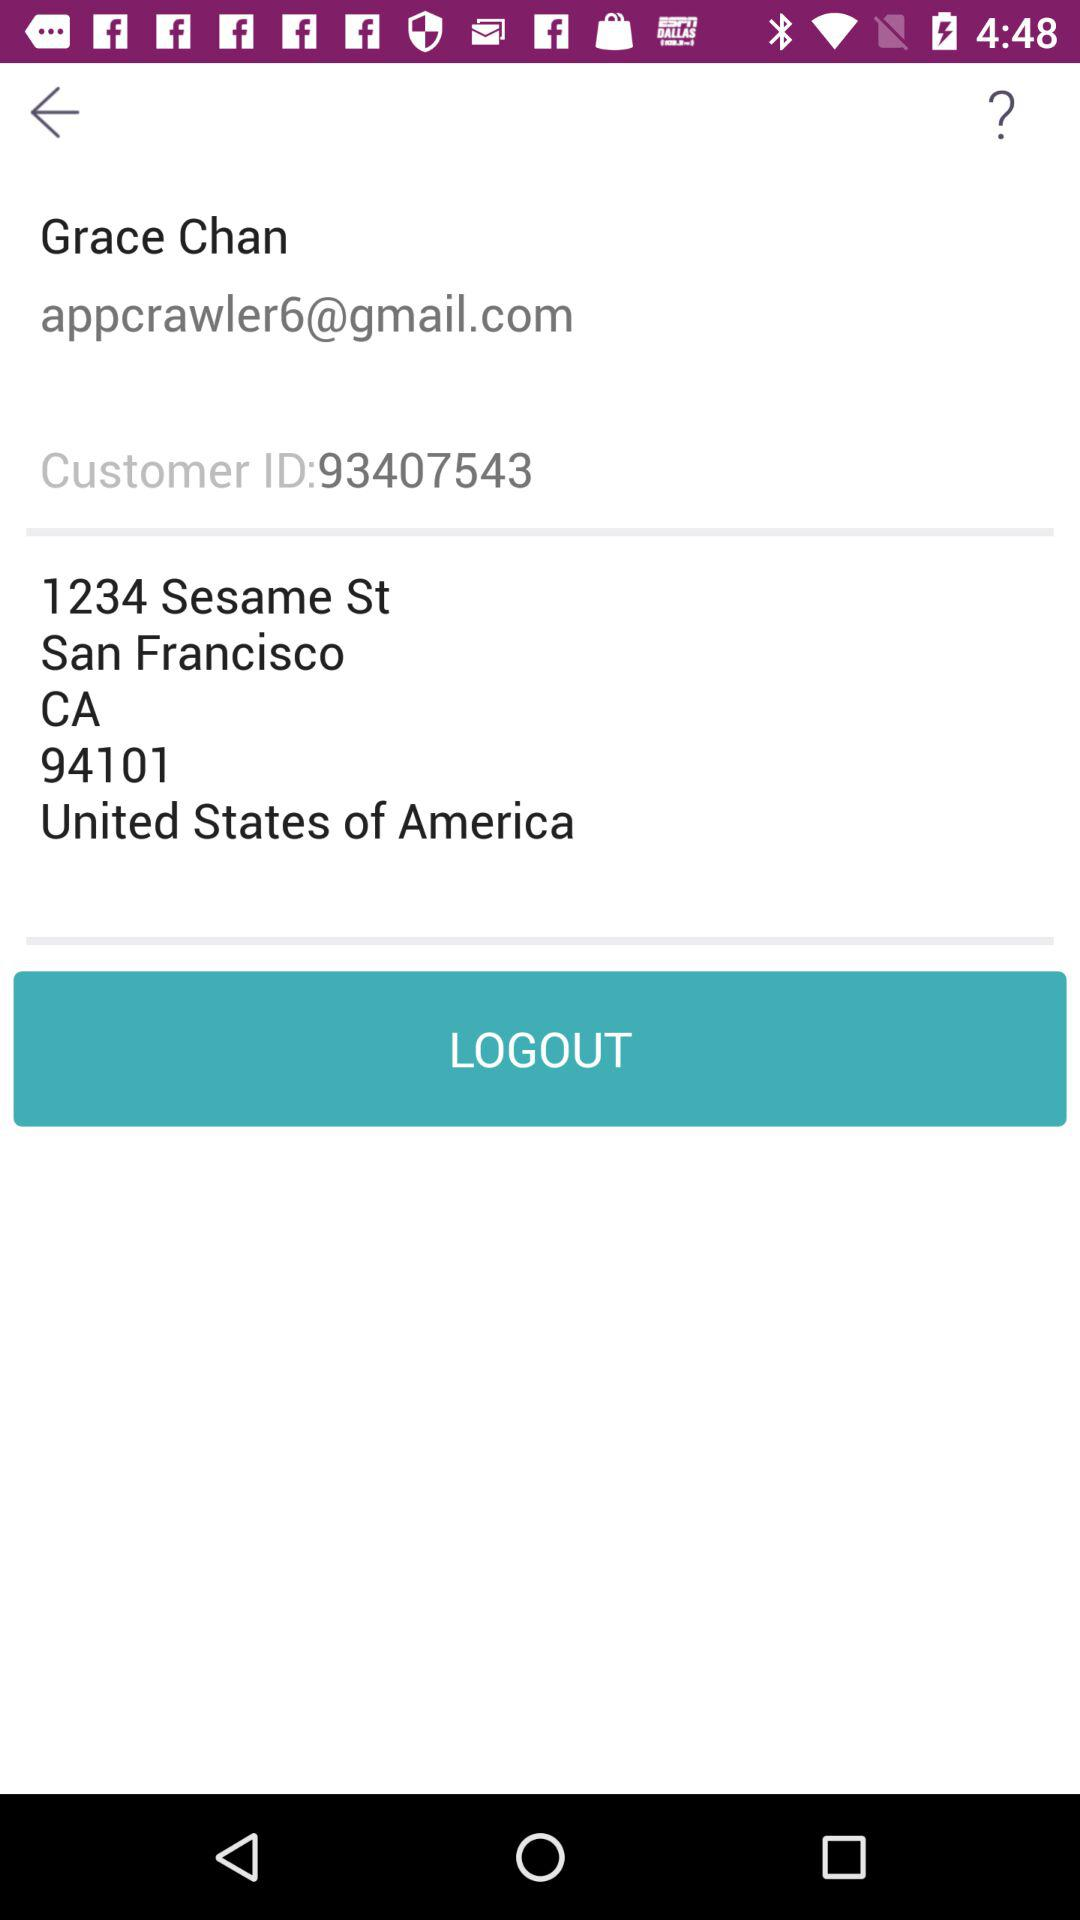What is the customer identity of the user? The customer identity of the user is 93407543. 